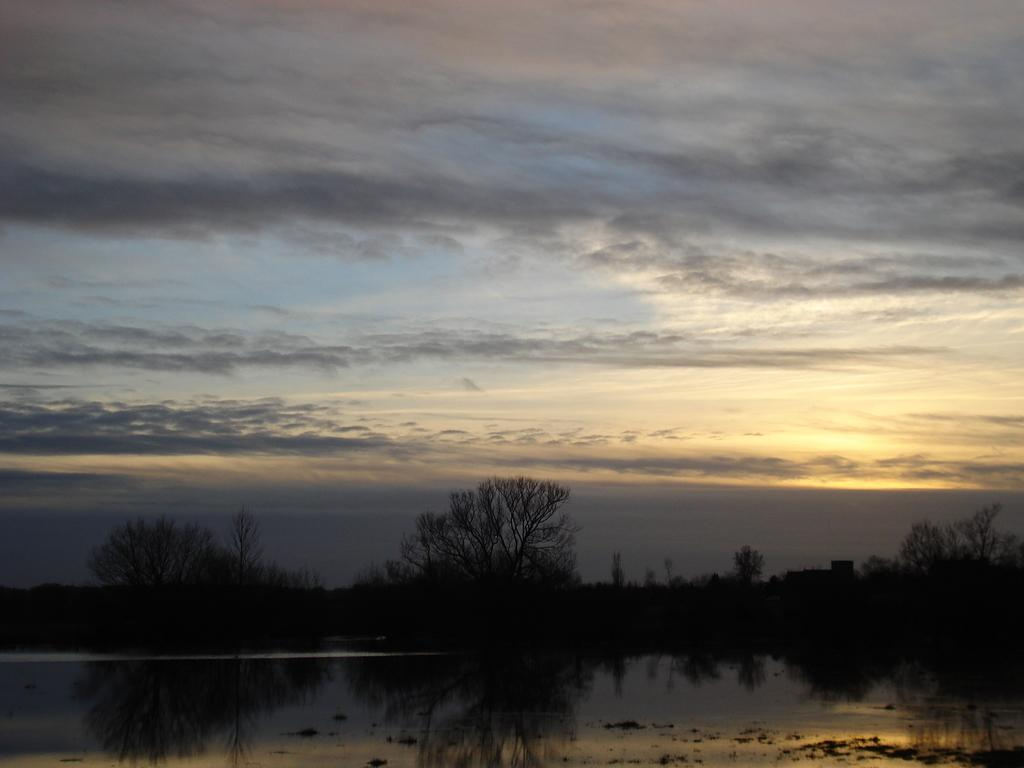What type of vegetation can be seen in the image? There are trees in the image. What body of water is present in the image? There is a lake in the image. What can be seen in the background of the image? The sky is visible in the background of the image. What is the condition of the sky in the image? There are clouds in the sky. Can you tell me how many rabbits are playing the drum in the image? There are no rabbits or drums present in the image. 